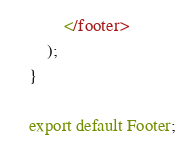<code> <loc_0><loc_0><loc_500><loc_500><_JavaScript_>        </footer>
    );
}

export default Footer;
</code> 